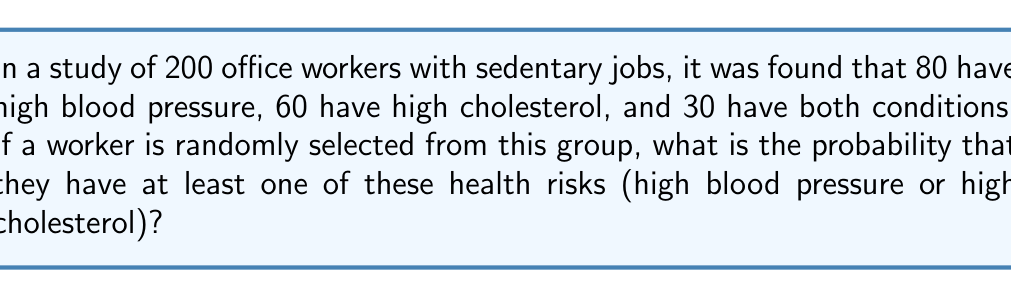Could you help me with this problem? Let's approach this step-by-step using set theory and the addition principle of probability:

1) Let A be the event of having high blood pressure, and B be the event of having high cholesterol.

2) We're given:
   $n(A) = 80$ (number of workers with high blood pressure)
   $n(B) = 60$ (number of workers with high cholesterol)
   $n(A \cap B) = 30$ (number of workers with both conditions)
   Total population = 200

3) We need to find $P(A \cup B)$, the probability of having at least one condition.

4) The addition principle of probability states:
   $P(A \cup B) = P(A) + P(B) - P(A \cap B)$

5) Calculate each probability:
   $P(A) = \frac{80}{200} = 0.4$
   $P(B) = \frac{60}{200} = 0.3$
   $P(A \cap B) = \frac{30}{200} = 0.15$

6) Substitute into the formula:
   $P(A \cup B) = 0.4 + 0.3 - 0.15 = 0.55$

Therefore, the probability of a randomly selected worker having at least one of these health risks is 0.55 or 55%.
Answer: 0.55 